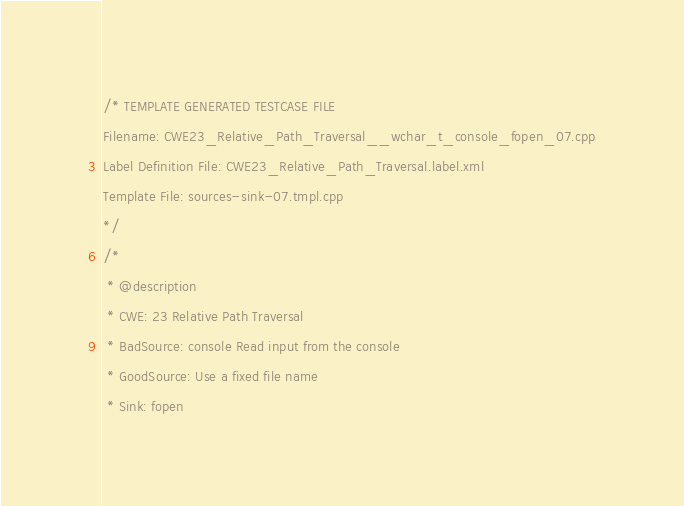Convert code to text. <code><loc_0><loc_0><loc_500><loc_500><_C++_>/* TEMPLATE GENERATED TESTCASE FILE
Filename: CWE23_Relative_Path_Traversal__wchar_t_console_fopen_07.cpp
Label Definition File: CWE23_Relative_Path_Traversal.label.xml
Template File: sources-sink-07.tmpl.cpp
*/
/*
 * @description
 * CWE: 23 Relative Path Traversal
 * BadSource: console Read input from the console
 * GoodSource: Use a fixed file name
 * Sink: fopen</code> 